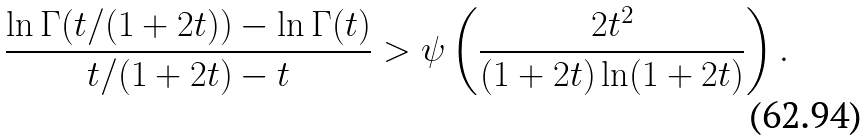Convert formula to latex. <formula><loc_0><loc_0><loc_500><loc_500>\frac { \ln \Gamma ( t / ( 1 + 2 t ) ) - \ln \Gamma ( t ) } { t / ( 1 + 2 t ) - t } > \psi \left ( \frac { 2 t ^ { 2 } } { ( 1 + 2 t ) \ln ( 1 + 2 t ) } \right ) .</formula> 